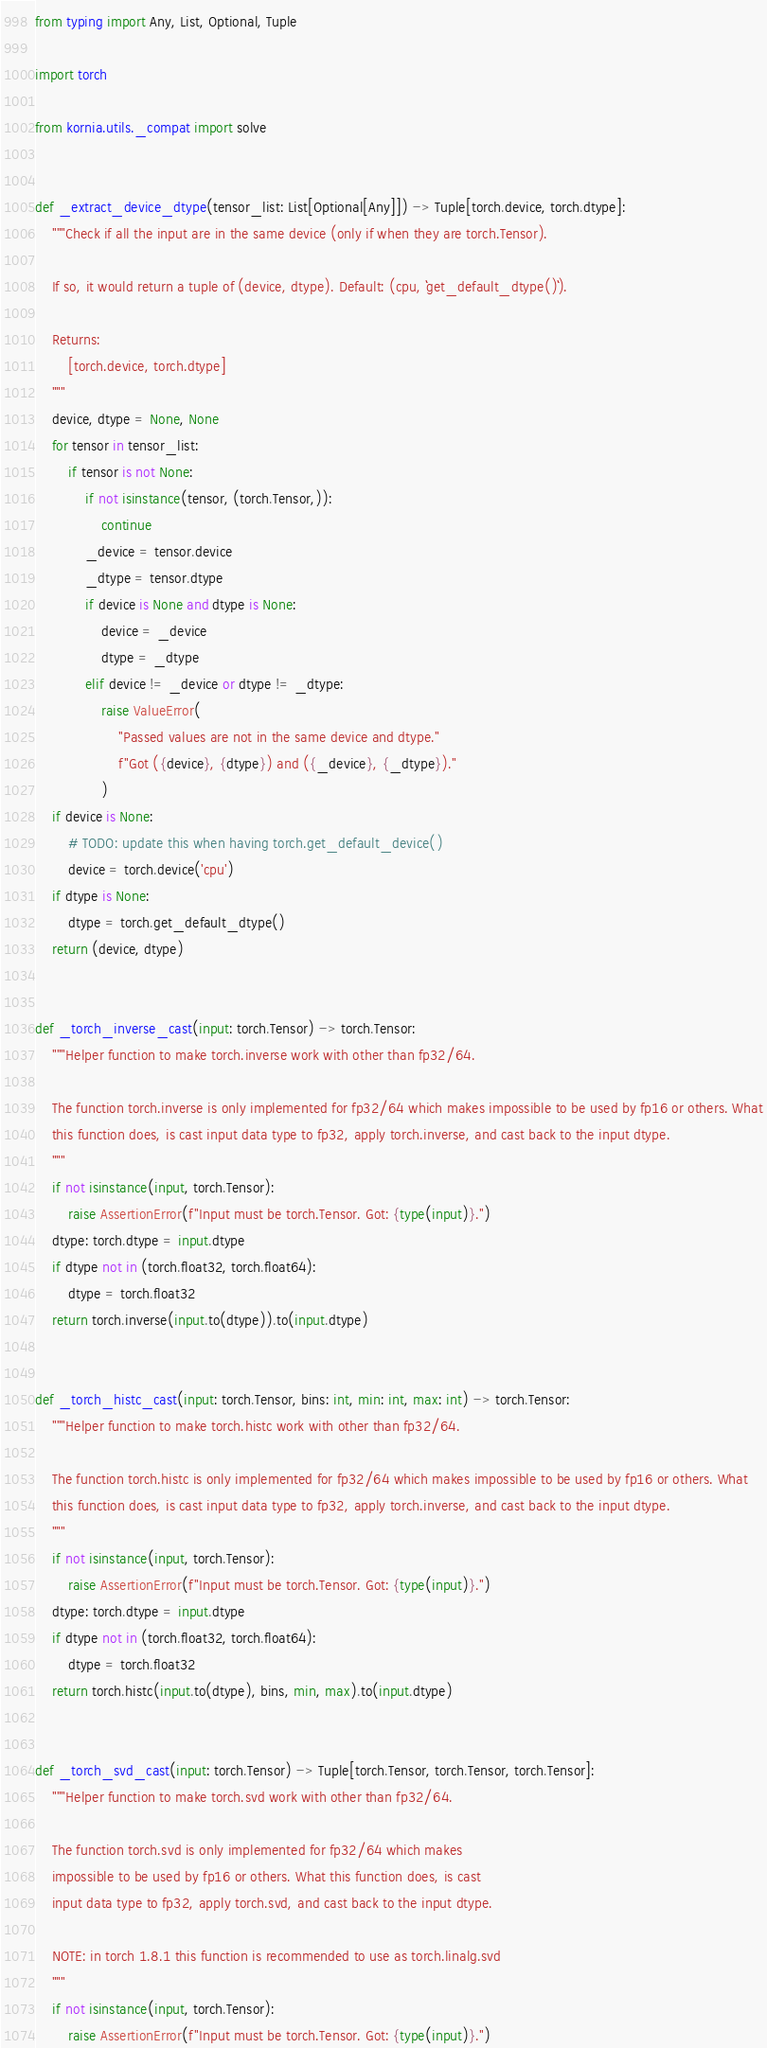<code> <loc_0><loc_0><loc_500><loc_500><_Python_>from typing import Any, List, Optional, Tuple

import torch

from kornia.utils._compat import solve


def _extract_device_dtype(tensor_list: List[Optional[Any]]) -> Tuple[torch.device, torch.dtype]:
    """Check if all the input are in the same device (only if when they are torch.Tensor).

    If so, it would return a tuple of (device, dtype). Default: (cpu, ``get_default_dtype()``).

    Returns:
        [torch.device, torch.dtype]
    """
    device, dtype = None, None
    for tensor in tensor_list:
        if tensor is not None:
            if not isinstance(tensor, (torch.Tensor,)):
                continue
            _device = tensor.device
            _dtype = tensor.dtype
            if device is None and dtype is None:
                device = _device
                dtype = _dtype
            elif device != _device or dtype != _dtype:
                raise ValueError(
                    "Passed values are not in the same device and dtype."
                    f"Got ({device}, {dtype}) and ({_device}, {_dtype})."
                )
    if device is None:
        # TODO: update this when having torch.get_default_device()
        device = torch.device('cpu')
    if dtype is None:
        dtype = torch.get_default_dtype()
    return (device, dtype)


def _torch_inverse_cast(input: torch.Tensor) -> torch.Tensor:
    """Helper function to make torch.inverse work with other than fp32/64.

    The function torch.inverse is only implemented for fp32/64 which makes impossible to be used by fp16 or others. What
    this function does, is cast input data type to fp32, apply torch.inverse, and cast back to the input dtype.
    """
    if not isinstance(input, torch.Tensor):
        raise AssertionError(f"Input must be torch.Tensor. Got: {type(input)}.")
    dtype: torch.dtype = input.dtype
    if dtype not in (torch.float32, torch.float64):
        dtype = torch.float32
    return torch.inverse(input.to(dtype)).to(input.dtype)


def _torch_histc_cast(input: torch.Tensor, bins: int, min: int, max: int) -> torch.Tensor:
    """Helper function to make torch.histc work with other than fp32/64.

    The function torch.histc is only implemented for fp32/64 which makes impossible to be used by fp16 or others. What
    this function does, is cast input data type to fp32, apply torch.inverse, and cast back to the input dtype.
    """
    if not isinstance(input, torch.Tensor):
        raise AssertionError(f"Input must be torch.Tensor. Got: {type(input)}.")
    dtype: torch.dtype = input.dtype
    if dtype not in (torch.float32, torch.float64):
        dtype = torch.float32
    return torch.histc(input.to(dtype), bins, min, max).to(input.dtype)


def _torch_svd_cast(input: torch.Tensor) -> Tuple[torch.Tensor, torch.Tensor, torch.Tensor]:
    """Helper function to make torch.svd work with other than fp32/64.

    The function torch.svd is only implemented for fp32/64 which makes
    impossible to be used by fp16 or others. What this function does, is cast
    input data type to fp32, apply torch.svd, and cast back to the input dtype.

    NOTE: in torch 1.8.1 this function is recommended to use as torch.linalg.svd
    """
    if not isinstance(input, torch.Tensor):
        raise AssertionError(f"Input must be torch.Tensor. Got: {type(input)}.")</code> 